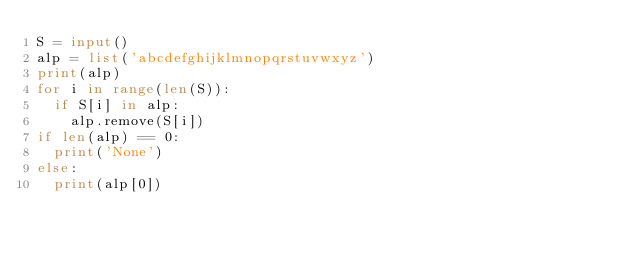<code> <loc_0><loc_0><loc_500><loc_500><_Python_>S = input()
alp = list('abcdefghijklmnopqrstuvwxyz')
print(alp)
for i in range(len(S)):
  if S[i] in alp:
    alp.remove(S[i])
if len(alp) == 0:
  print('None')
else:
  print(alp[0])</code> 